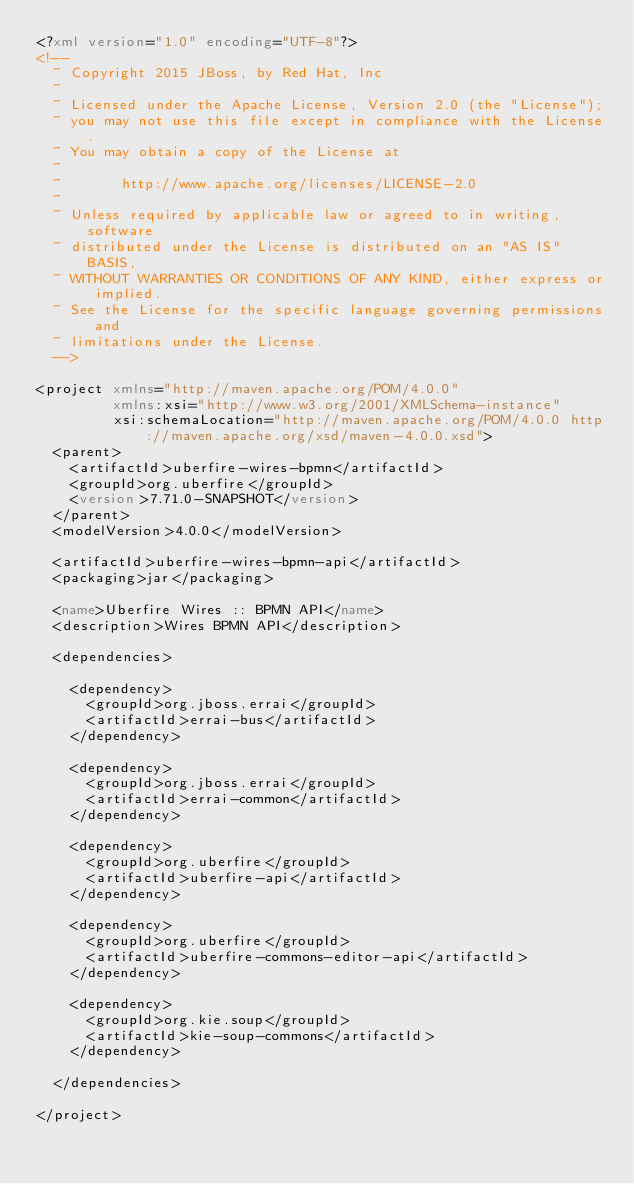<code> <loc_0><loc_0><loc_500><loc_500><_XML_><?xml version="1.0" encoding="UTF-8"?>
<!--
  ~ Copyright 2015 JBoss, by Red Hat, Inc
  ~
  ~ Licensed under the Apache License, Version 2.0 (the "License");
  ~ you may not use this file except in compliance with the License.
  ~ You may obtain a copy of the License at
  ~
  ~       http://www.apache.org/licenses/LICENSE-2.0
  ~
  ~ Unless required by applicable law or agreed to in writing, software
  ~ distributed under the License is distributed on an "AS IS" BASIS,
  ~ WITHOUT WARRANTIES OR CONDITIONS OF ANY KIND, either express or implied.
  ~ See the License for the specific language governing permissions and
  ~ limitations under the License.
  -->

<project xmlns="http://maven.apache.org/POM/4.0.0"
         xmlns:xsi="http://www.w3.org/2001/XMLSchema-instance"
         xsi:schemaLocation="http://maven.apache.org/POM/4.0.0 http://maven.apache.org/xsd/maven-4.0.0.xsd">
  <parent>
    <artifactId>uberfire-wires-bpmn</artifactId>
    <groupId>org.uberfire</groupId>
    <version>7.71.0-SNAPSHOT</version>
  </parent>
  <modelVersion>4.0.0</modelVersion>

  <artifactId>uberfire-wires-bpmn-api</artifactId>
  <packaging>jar</packaging>

  <name>Uberfire Wires :: BPMN API</name>
  <description>Wires BPMN API</description>

  <dependencies>

    <dependency>
      <groupId>org.jboss.errai</groupId>
      <artifactId>errai-bus</artifactId>
    </dependency>

    <dependency>
      <groupId>org.jboss.errai</groupId>
      <artifactId>errai-common</artifactId>
    </dependency>

    <dependency>
      <groupId>org.uberfire</groupId>
      <artifactId>uberfire-api</artifactId>
    </dependency>

    <dependency>
      <groupId>org.uberfire</groupId>
      <artifactId>uberfire-commons-editor-api</artifactId>
    </dependency>

    <dependency>
      <groupId>org.kie.soup</groupId>
      <artifactId>kie-soup-commons</artifactId>
    </dependency>

  </dependencies>

</project>
</code> 